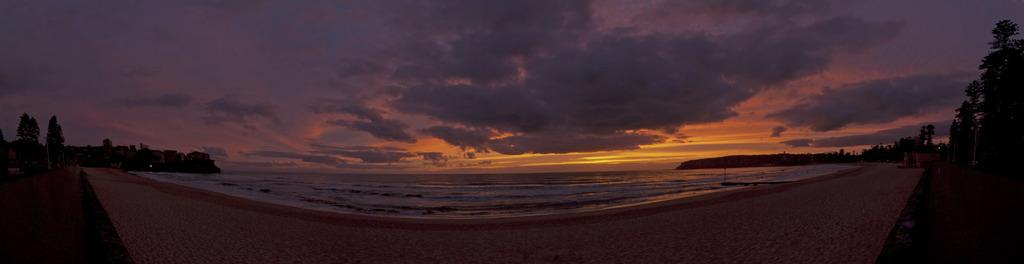What type of natural environment is depicted in the image? The image contains sand and water, suggesting a beach or coastal area. What can be seen on the left side of the image? There are trees on the left side of the image. What can be seen on the right side of the image? There are trees on the right side of the image. What is visible in the background of the image? The sky is visible in the background of the image. What is the weather like in the image? The sky is cloudy, indicating that the weather might be overcast or partly cloudy. What time of day is it in the image, and what is the name of the downtown area nearby? The time of day cannot be determined from the image, and there is no mention of a downtown area in the provided facts. 